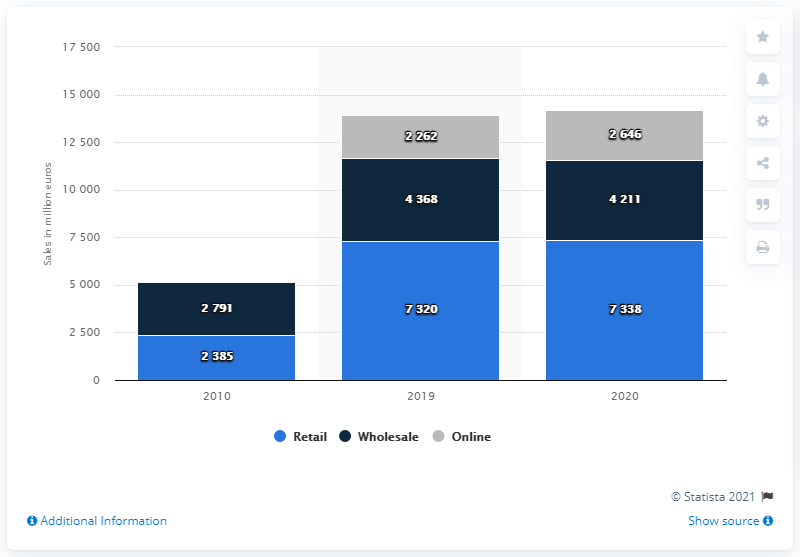Give some essential details in this illustration. The Richemont Group generated $7338 in sales through its global retail channel in FY2020. 